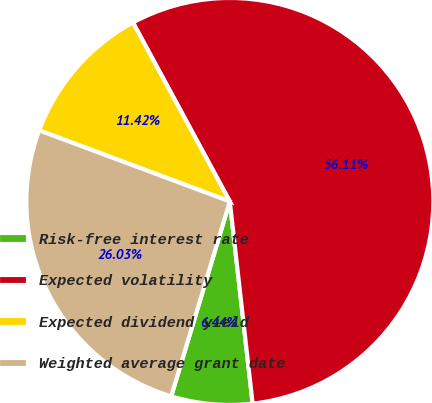Convert chart. <chart><loc_0><loc_0><loc_500><loc_500><pie_chart><fcel>Risk-free interest rate<fcel>Expected volatility<fcel>Expected dividend yield<fcel>Weighted average grant date<nl><fcel>6.44%<fcel>56.11%<fcel>11.42%<fcel>26.03%<nl></chart> 